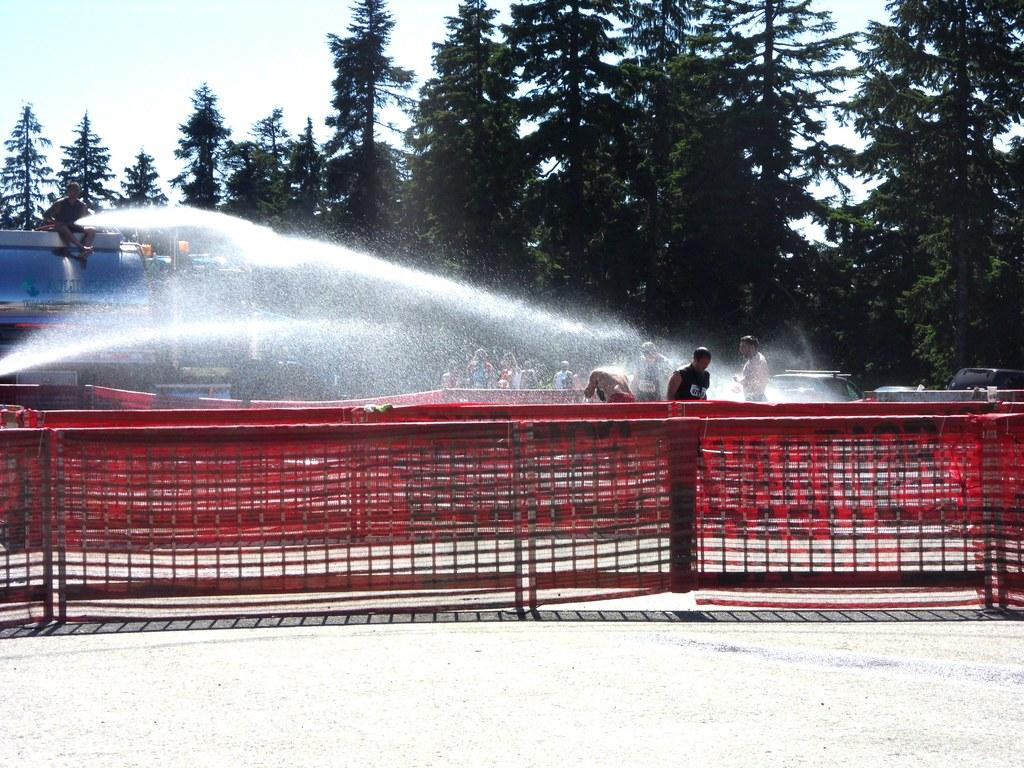What type of fencing is present in the image? There is red color fencing in the image. Can you describe the people in the image? There are people in the image, including a person sitting on the tanker. What is the large object in the image? There is a tanker in the image. What can be seen in the background of the image? There is water visible in the image, as well as trees and the sky. What else is present in the image? There are vehicles in the image. What color are the eyes of the person's sister in the image? There is no mention of a sister or eyes in the image, so this information cannot be determined. 